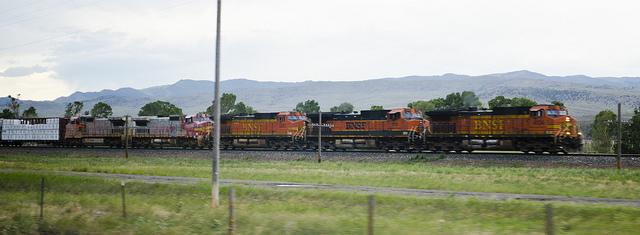What is on top of the fence?
Write a very short answer. Nothing. Why are those poles in the picture?
Answer briefly. Power lines. What color is the train?
Answer briefly. Orange. What color is the first train car?
Be succinct. Orange. 